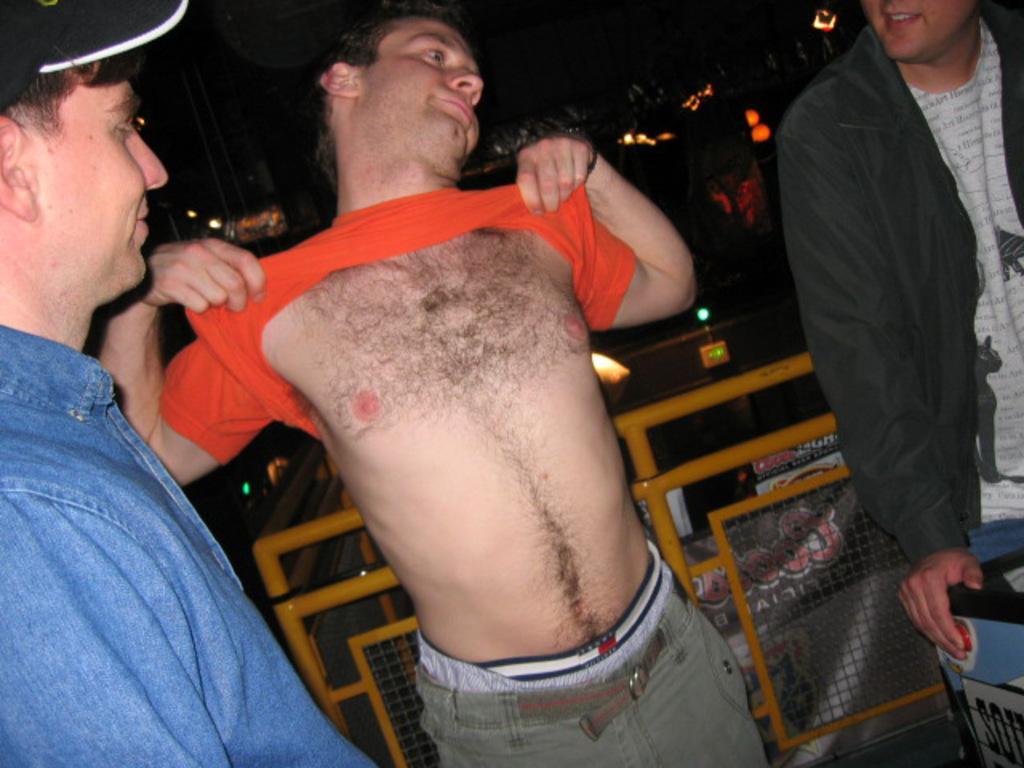In one or two sentences, can you explain what this image depicts? In this image we can see three men standing. On the backside we can see a metal fence, poles and some lights. On the right side we can see the hand of a person on an object. 